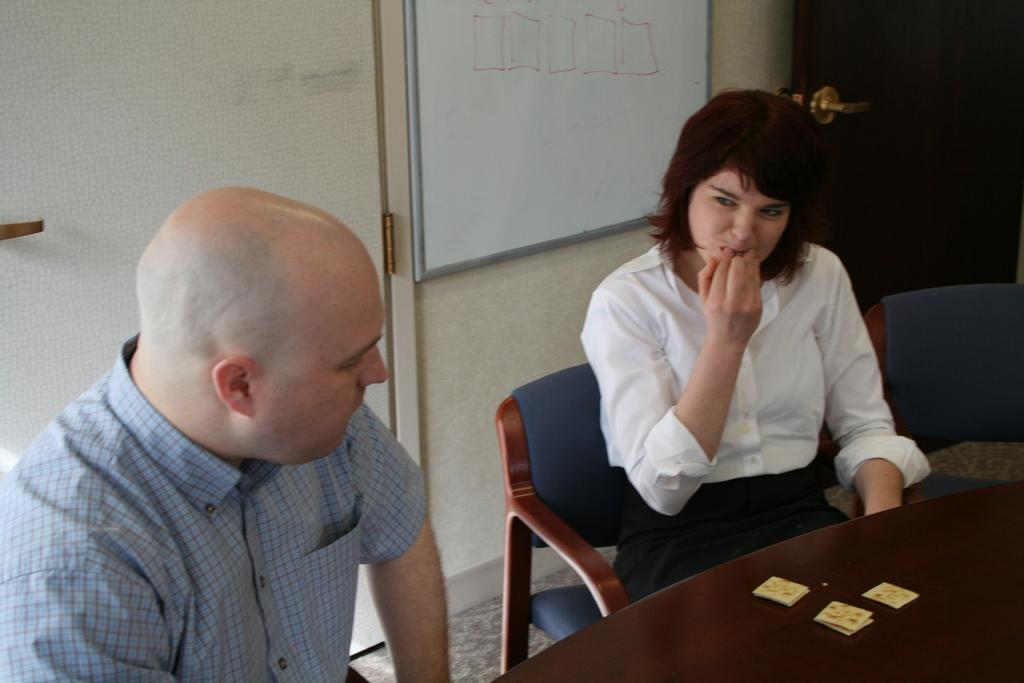How many people are in the image? There are two people in the image, a man and a woman. What are the man and woman doing in the image? Both the man and woman are seated on chairs. What is in front of the chairs? There is a table in front of the chairs. What is behind the chairs? There is a door behind the chairs. What is beside the door? There is a board beside the door. What type of game are the man and woman playing in the image? There is no game being played in the image; the man and woman are simply seated on chairs. 